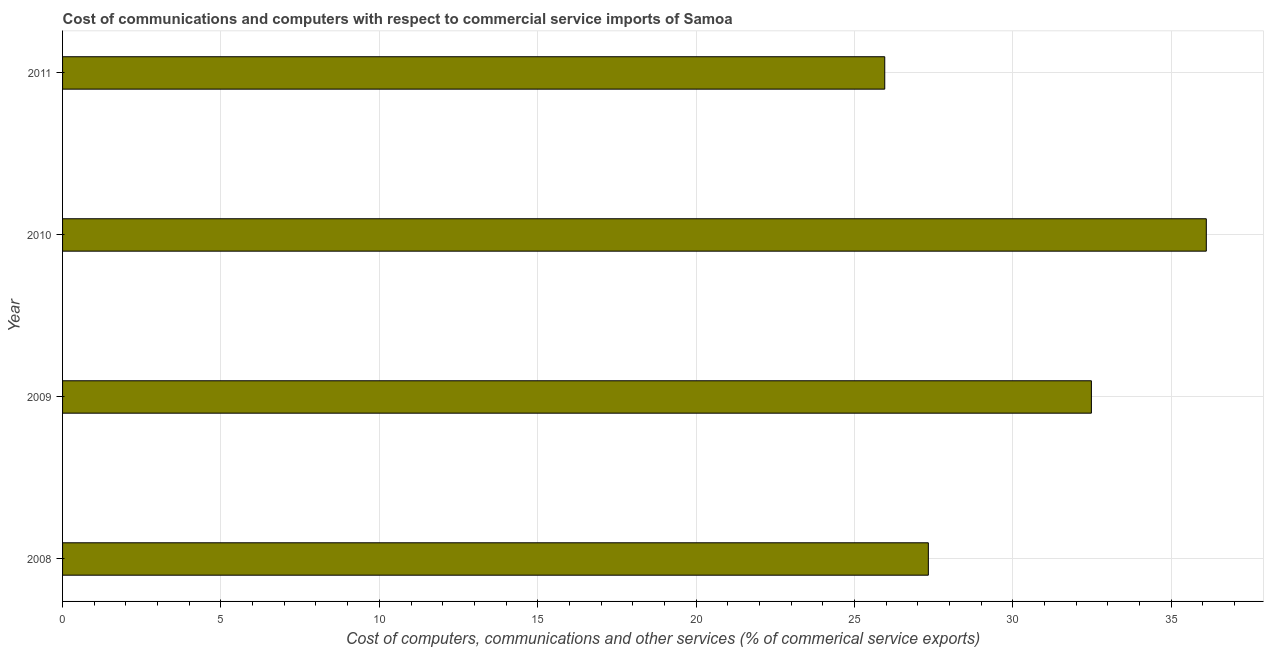Does the graph contain grids?
Give a very brief answer. Yes. What is the title of the graph?
Your answer should be compact. Cost of communications and computers with respect to commercial service imports of Samoa. What is the label or title of the X-axis?
Offer a very short reply. Cost of computers, communications and other services (% of commerical service exports). What is the label or title of the Y-axis?
Provide a succinct answer. Year. What is the  computer and other services in 2011?
Your answer should be very brief. 25.96. Across all years, what is the maximum  computer and other services?
Keep it short and to the point. 36.11. Across all years, what is the minimum cost of communications?
Your answer should be compact. 25.96. In which year was the cost of communications minimum?
Your answer should be compact. 2011. What is the sum of the  computer and other services?
Offer a terse response. 121.87. What is the difference between the  computer and other services in 2009 and 2010?
Keep it short and to the point. -3.63. What is the average  computer and other services per year?
Your answer should be compact. 30.47. What is the median cost of communications?
Keep it short and to the point. 29.91. What is the ratio of the  computer and other services in 2008 to that in 2011?
Your answer should be compact. 1.05. Is the cost of communications in 2009 less than that in 2011?
Your response must be concise. No. Is the difference between the cost of communications in 2009 and 2011 greater than the difference between any two years?
Keep it short and to the point. No. What is the difference between the highest and the second highest cost of communications?
Offer a very short reply. 3.63. Is the sum of the cost of communications in 2009 and 2010 greater than the maximum cost of communications across all years?
Make the answer very short. Yes. What is the difference between the highest and the lowest cost of communications?
Offer a very short reply. 10.15. In how many years, is the cost of communications greater than the average cost of communications taken over all years?
Offer a very short reply. 2. How many bars are there?
Provide a succinct answer. 4. How many years are there in the graph?
Ensure brevity in your answer.  4. Are the values on the major ticks of X-axis written in scientific E-notation?
Make the answer very short. No. What is the Cost of computers, communications and other services (% of commerical service exports) of 2008?
Ensure brevity in your answer.  27.33. What is the Cost of computers, communications and other services (% of commerical service exports) in 2009?
Ensure brevity in your answer.  32.48. What is the Cost of computers, communications and other services (% of commerical service exports) in 2010?
Give a very brief answer. 36.11. What is the Cost of computers, communications and other services (% of commerical service exports) of 2011?
Make the answer very short. 25.96. What is the difference between the Cost of computers, communications and other services (% of commerical service exports) in 2008 and 2009?
Keep it short and to the point. -5.15. What is the difference between the Cost of computers, communications and other services (% of commerical service exports) in 2008 and 2010?
Offer a very short reply. -8.77. What is the difference between the Cost of computers, communications and other services (% of commerical service exports) in 2008 and 2011?
Offer a very short reply. 1.38. What is the difference between the Cost of computers, communications and other services (% of commerical service exports) in 2009 and 2010?
Your answer should be compact. -3.63. What is the difference between the Cost of computers, communications and other services (% of commerical service exports) in 2009 and 2011?
Offer a terse response. 6.52. What is the difference between the Cost of computers, communications and other services (% of commerical service exports) in 2010 and 2011?
Your response must be concise. 10.15. What is the ratio of the Cost of computers, communications and other services (% of commerical service exports) in 2008 to that in 2009?
Ensure brevity in your answer.  0.84. What is the ratio of the Cost of computers, communications and other services (% of commerical service exports) in 2008 to that in 2010?
Make the answer very short. 0.76. What is the ratio of the Cost of computers, communications and other services (% of commerical service exports) in 2008 to that in 2011?
Your response must be concise. 1.05. What is the ratio of the Cost of computers, communications and other services (% of commerical service exports) in 2009 to that in 2011?
Give a very brief answer. 1.25. What is the ratio of the Cost of computers, communications and other services (% of commerical service exports) in 2010 to that in 2011?
Your answer should be very brief. 1.39. 